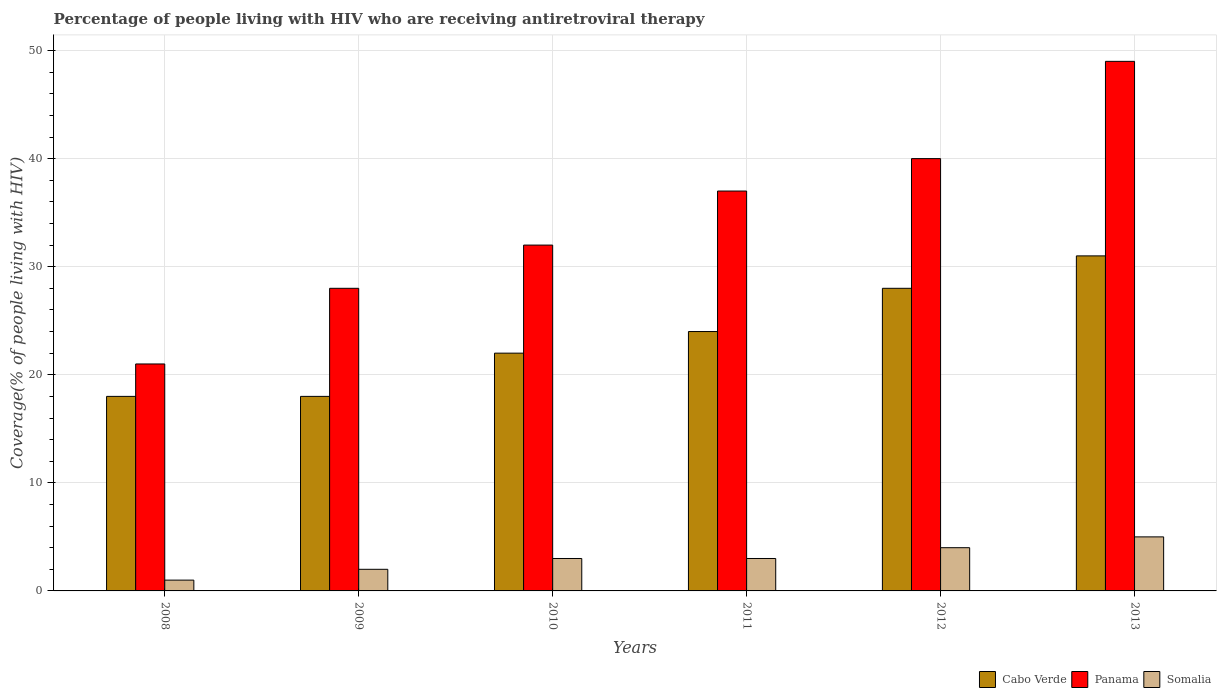Are the number of bars on each tick of the X-axis equal?
Your response must be concise. Yes. How many bars are there on the 1st tick from the left?
Ensure brevity in your answer.  3. What is the label of the 5th group of bars from the left?
Your response must be concise. 2012. What is the percentage of the HIV infected people who are receiving antiretroviral therapy in Cabo Verde in 2013?
Ensure brevity in your answer.  31. Across all years, what is the maximum percentage of the HIV infected people who are receiving antiretroviral therapy in Panama?
Provide a succinct answer. 49. Across all years, what is the minimum percentage of the HIV infected people who are receiving antiretroviral therapy in Cabo Verde?
Your answer should be compact. 18. In which year was the percentage of the HIV infected people who are receiving antiretroviral therapy in Somalia minimum?
Provide a short and direct response. 2008. What is the total percentage of the HIV infected people who are receiving antiretroviral therapy in Panama in the graph?
Provide a short and direct response. 207. What is the difference between the percentage of the HIV infected people who are receiving antiretroviral therapy in Panama in 2008 and that in 2009?
Your response must be concise. -7. What is the difference between the percentage of the HIV infected people who are receiving antiretroviral therapy in Cabo Verde in 2011 and the percentage of the HIV infected people who are receiving antiretroviral therapy in Somalia in 2012?
Provide a succinct answer. 20. In the year 2009, what is the difference between the percentage of the HIV infected people who are receiving antiretroviral therapy in Somalia and percentage of the HIV infected people who are receiving antiretroviral therapy in Panama?
Provide a short and direct response. -26. In how many years, is the percentage of the HIV infected people who are receiving antiretroviral therapy in Cabo Verde greater than 8 %?
Offer a very short reply. 6. What is the ratio of the percentage of the HIV infected people who are receiving antiretroviral therapy in Panama in 2012 to that in 2013?
Your response must be concise. 0.82. Is the difference between the percentage of the HIV infected people who are receiving antiretroviral therapy in Somalia in 2010 and 2013 greater than the difference between the percentage of the HIV infected people who are receiving antiretroviral therapy in Panama in 2010 and 2013?
Give a very brief answer. Yes. What is the difference between the highest and the lowest percentage of the HIV infected people who are receiving antiretroviral therapy in Somalia?
Provide a short and direct response. 4. In how many years, is the percentage of the HIV infected people who are receiving antiretroviral therapy in Somalia greater than the average percentage of the HIV infected people who are receiving antiretroviral therapy in Somalia taken over all years?
Give a very brief answer. 2. Is the sum of the percentage of the HIV infected people who are receiving antiretroviral therapy in Somalia in 2008 and 2012 greater than the maximum percentage of the HIV infected people who are receiving antiretroviral therapy in Panama across all years?
Your answer should be very brief. No. What does the 3rd bar from the left in 2012 represents?
Make the answer very short. Somalia. What does the 3rd bar from the right in 2011 represents?
Provide a succinct answer. Cabo Verde. Is it the case that in every year, the sum of the percentage of the HIV infected people who are receiving antiretroviral therapy in Cabo Verde and percentage of the HIV infected people who are receiving antiretroviral therapy in Panama is greater than the percentage of the HIV infected people who are receiving antiretroviral therapy in Somalia?
Make the answer very short. Yes. How many bars are there?
Make the answer very short. 18. How many years are there in the graph?
Your response must be concise. 6. What is the difference between two consecutive major ticks on the Y-axis?
Provide a short and direct response. 10. Does the graph contain any zero values?
Provide a short and direct response. No. Does the graph contain grids?
Provide a short and direct response. Yes. Where does the legend appear in the graph?
Give a very brief answer. Bottom right. What is the title of the graph?
Offer a very short reply. Percentage of people living with HIV who are receiving antiretroviral therapy. What is the label or title of the Y-axis?
Ensure brevity in your answer.  Coverage(% of people living with HIV). What is the Coverage(% of people living with HIV) of Panama in 2008?
Make the answer very short. 21. What is the Coverage(% of people living with HIV) of Cabo Verde in 2009?
Your response must be concise. 18. What is the Coverage(% of people living with HIV) in Somalia in 2009?
Ensure brevity in your answer.  2. What is the Coverage(% of people living with HIV) in Cabo Verde in 2010?
Ensure brevity in your answer.  22. What is the Coverage(% of people living with HIV) in Somalia in 2010?
Your response must be concise. 3. What is the Coverage(% of people living with HIV) in Cabo Verde in 2011?
Provide a short and direct response. 24. What is the Coverage(% of people living with HIV) in Somalia in 2011?
Make the answer very short. 3. What is the Coverage(% of people living with HIV) of Cabo Verde in 2012?
Offer a terse response. 28. What is the Coverage(% of people living with HIV) of Somalia in 2012?
Your answer should be compact. 4. What is the Coverage(% of people living with HIV) of Somalia in 2013?
Your response must be concise. 5. Across all years, what is the maximum Coverage(% of people living with HIV) of Cabo Verde?
Provide a short and direct response. 31. Across all years, what is the minimum Coverage(% of people living with HIV) in Somalia?
Give a very brief answer. 1. What is the total Coverage(% of people living with HIV) of Cabo Verde in the graph?
Your answer should be very brief. 141. What is the total Coverage(% of people living with HIV) of Panama in the graph?
Make the answer very short. 207. What is the difference between the Coverage(% of people living with HIV) in Panama in 2008 and that in 2009?
Give a very brief answer. -7. What is the difference between the Coverage(% of people living with HIV) of Panama in 2008 and that in 2010?
Offer a terse response. -11. What is the difference between the Coverage(% of people living with HIV) of Somalia in 2008 and that in 2010?
Your answer should be compact. -2. What is the difference between the Coverage(% of people living with HIV) in Cabo Verde in 2008 and that in 2011?
Ensure brevity in your answer.  -6. What is the difference between the Coverage(% of people living with HIV) of Somalia in 2008 and that in 2011?
Provide a succinct answer. -2. What is the difference between the Coverage(% of people living with HIV) of Cabo Verde in 2008 and that in 2012?
Provide a succinct answer. -10. What is the difference between the Coverage(% of people living with HIV) of Somalia in 2008 and that in 2012?
Your answer should be very brief. -3. What is the difference between the Coverage(% of people living with HIV) of Cabo Verde in 2008 and that in 2013?
Provide a succinct answer. -13. What is the difference between the Coverage(% of people living with HIV) in Panama in 2008 and that in 2013?
Ensure brevity in your answer.  -28. What is the difference between the Coverage(% of people living with HIV) of Somalia in 2008 and that in 2013?
Your answer should be compact. -4. What is the difference between the Coverage(% of people living with HIV) of Cabo Verde in 2009 and that in 2010?
Offer a very short reply. -4. What is the difference between the Coverage(% of people living with HIV) of Somalia in 2009 and that in 2010?
Offer a terse response. -1. What is the difference between the Coverage(% of people living with HIV) of Somalia in 2009 and that in 2011?
Your response must be concise. -1. What is the difference between the Coverage(% of people living with HIV) of Panama in 2009 and that in 2012?
Provide a succinct answer. -12. What is the difference between the Coverage(% of people living with HIV) in Somalia in 2009 and that in 2013?
Your answer should be very brief. -3. What is the difference between the Coverage(% of people living with HIV) in Cabo Verde in 2010 and that in 2011?
Provide a succinct answer. -2. What is the difference between the Coverage(% of people living with HIV) of Panama in 2010 and that in 2011?
Provide a short and direct response. -5. What is the difference between the Coverage(% of people living with HIV) in Panama in 2010 and that in 2012?
Provide a succinct answer. -8. What is the difference between the Coverage(% of people living with HIV) in Cabo Verde in 2010 and that in 2013?
Make the answer very short. -9. What is the difference between the Coverage(% of people living with HIV) of Panama in 2010 and that in 2013?
Make the answer very short. -17. What is the difference between the Coverage(% of people living with HIV) of Somalia in 2010 and that in 2013?
Provide a short and direct response. -2. What is the difference between the Coverage(% of people living with HIV) in Cabo Verde in 2011 and that in 2012?
Provide a succinct answer. -4. What is the difference between the Coverage(% of people living with HIV) of Panama in 2011 and that in 2013?
Give a very brief answer. -12. What is the difference between the Coverage(% of people living with HIV) in Somalia in 2011 and that in 2013?
Your answer should be very brief. -2. What is the difference between the Coverage(% of people living with HIV) of Cabo Verde in 2012 and that in 2013?
Provide a succinct answer. -3. What is the difference between the Coverage(% of people living with HIV) in Panama in 2012 and that in 2013?
Offer a terse response. -9. What is the difference between the Coverage(% of people living with HIV) of Somalia in 2012 and that in 2013?
Your answer should be very brief. -1. What is the difference between the Coverage(% of people living with HIV) in Cabo Verde in 2008 and the Coverage(% of people living with HIV) in Panama in 2009?
Make the answer very short. -10. What is the difference between the Coverage(% of people living with HIV) in Cabo Verde in 2008 and the Coverage(% of people living with HIV) in Somalia in 2009?
Your answer should be very brief. 16. What is the difference between the Coverage(% of people living with HIV) of Cabo Verde in 2008 and the Coverage(% of people living with HIV) of Somalia in 2010?
Keep it short and to the point. 15. What is the difference between the Coverage(% of people living with HIV) in Panama in 2008 and the Coverage(% of people living with HIV) in Somalia in 2010?
Offer a very short reply. 18. What is the difference between the Coverage(% of people living with HIV) of Cabo Verde in 2008 and the Coverage(% of people living with HIV) of Panama in 2011?
Make the answer very short. -19. What is the difference between the Coverage(% of people living with HIV) in Panama in 2008 and the Coverage(% of people living with HIV) in Somalia in 2011?
Give a very brief answer. 18. What is the difference between the Coverage(% of people living with HIV) in Cabo Verde in 2008 and the Coverage(% of people living with HIV) in Panama in 2012?
Offer a very short reply. -22. What is the difference between the Coverage(% of people living with HIV) in Cabo Verde in 2008 and the Coverage(% of people living with HIV) in Panama in 2013?
Offer a very short reply. -31. What is the difference between the Coverage(% of people living with HIV) in Panama in 2008 and the Coverage(% of people living with HIV) in Somalia in 2013?
Your answer should be very brief. 16. What is the difference between the Coverage(% of people living with HIV) in Cabo Verde in 2009 and the Coverage(% of people living with HIV) in Somalia in 2010?
Your answer should be compact. 15. What is the difference between the Coverage(% of people living with HIV) in Cabo Verde in 2009 and the Coverage(% of people living with HIV) in Somalia in 2011?
Give a very brief answer. 15. What is the difference between the Coverage(% of people living with HIV) of Panama in 2009 and the Coverage(% of people living with HIV) of Somalia in 2011?
Your response must be concise. 25. What is the difference between the Coverage(% of people living with HIV) in Cabo Verde in 2009 and the Coverage(% of people living with HIV) in Somalia in 2012?
Provide a short and direct response. 14. What is the difference between the Coverage(% of people living with HIV) of Cabo Verde in 2009 and the Coverage(% of people living with HIV) of Panama in 2013?
Make the answer very short. -31. What is the difference between the Coverage(% of people living with HIV) of Cabo Verde in 2009 and the Coverage(% of people living with HIV) of Somalia in 2013?
Your answer should be very brief. 13. What is the difference between the Coverage(% of people living with HIV) of Panama in 2009 and the Coverage(% of people living with HIV) of Somalia in 2013?
Ensure brevity in your answer.  23. What is the difference between the Coverage(% of people living with HIV) in Cabo Verde in 2010 and the Coverage(% of people living with HIV) in Panama in 2011?
Make the answer very short. -15. What is the difference between the Coverage(% of people living with HIV) of Cabo Verde in 2010 and the Coverage(% of people living with HIV) of Somalia in 2011?
Your answer should be compact. 19. What is the difference between the Coverage(% of people living with HIV) in Cabo Verde in 2010 and the Coverage(% of people living with HIV) in Panama in 2012?
Your answer should be compact. -18. What is the difference between the Coverage(% of people living with HIV) in Cabo Verde in 2010 and the Coverage(% of people living with HIV) in Somalia in 2012?
Give a very brief answer. 18. What is the difference between the Coverage(% of people living with HIV) of Cabo Verde in 2010 and the Coverage(% of people living with HIV) of Panama in 2013?
Ensure brevity in your answer.  -27. What is the difference between the Coverage(% of people living with HIV) in Cabo Verde in 2010 and the Coverage(% of people living with HIV) in Somalia in 2013?
Your answer should be very brief. 17. What is the difference between the Coverage(% of people living with HIV) in Panama in 2010 and the Coverage(% of people living with HIV) in Somalia in 2013?
Your answer should be very brief. 27. What is the difference between the Coverage(% of people living with HIV) in Panama in 2011 and the Coverage(% of people living with HIV) in Somalia in 2012?
Give a very brief answer. 33. What is the difference between the Coverage(% of people living with HIV) in Cabo Verde in 2011 and the Coverage(% of people living with HIV) in Panama in 2013?
Offer a terse response. -25. What is the difference between the Coverage(% of people living with HIV) in Panama in 2011 and the Coverage(% of people living with HIV) in Somalia in 2013?
Make the answer very short. 32. What is the average Coverage(% of people living with HIV) in Cabo Verde per year?
Your answer should be compact. 23.5. What is the average Coverage(% of people living with HIV) of Panama per year?
Keep it short and to the point. 34.5. What is the average Coverage(% of people living with HIV) in Somalia per year?
Your answer should be compact. 3. In the year 2008, what is the difference between the Coverage(% of people living with HIV) in Cabo Verde and Coverage(% of people living with HIV) in Panama?
Make the answer very short. -3. In the year 2008, what is the difference between the Coverage(% of people living with HIV) in Cabo Verde and Coverage(% of people living with HIV) in Somalia?
Your answer should be very brief. 17. In the year 2009, what is the difference between the Coverage(% of people living with HIV) in Cabo Verde and Coverage(% of people living with HIV) in Panama?
Make the answer very short. -10. In the year 2010, what is the difference between the Coverage(% of people living with HIV) of Cabo Verde and Coverage(% of people living with HIV) of Panama?
Provide a short and direct response. -10. In the year 2010, what is the difference between the Coverage(% of people living with HIV) of Cabo Verde and Coverage(% of people living with HIV) of Somalia?
Make the answer very short. 19. In the year 2010, what is the difference between the Coverage(% of people living with HIV) of Panama and Coverage(% of people living with HIV) of Somalia?
Your answer should be very brief. 29. In the year 2011, what is the difference between the Coverage(% of people living with HIV) in Cabo Verde and Coverage(% of people living with HIV) in Panama?
Your response must be concise. -13. In the year 2011, what is the difference between the Coverage(% of people living with HIV) of Cabo Verde and Coverage(% of people living with HIV) of Somalia?
Your response must be concise. 21. In the year 2011, what is the difference between the Coverage(% of people living with HIV) in Panama and Coverage(% of people living with HIV) in Somalia?
Your answer should be very brief. 34. In the year 2012, what is the difference between the Coverage(% of people living with HIV) in Cabo Verde and Coverage(% of people living with HIV) in Panama?
Provide a succinct answer. -12. In the year 2012, what is the difference between the Coverage(% of people living with HIV) in Panama and Coverage(% of people living with HIV) in Somalia?
Your answer should be compact. 36. In the year 2013, what is the difference between the Coverage(% of people living with HIV) of Cabo Verde and Coverage(% of people living with HIV) of Somalia?
Ensure brevity in your answer.  26. What is the ratio of the Coverage(% of people living with HIV) in Panama in 2008 to that in 2009?
Provide a short and direct response. 0.75. What is the ratio of the Coverage(% of people living with HIV) of Cabo Verde in 2008 to that in 2010?
Give a very brief answer. 0.82. What is the ratio of the Coverage(% of people living with HIV) of Panama in 2008 to that in 2010?
Offer a very short reply. 0.66. What is the ratio of the Coverage(% of people living with HIV) in Panama in 2008 to that in 2011?
Make the answer very short. 0.57. What is the ratio of the Coverage(% of people living with HIV) of Somalia in 2008 to that in 2011?
Offer a very short reply. 0.33. What is the ratio of the Coverage(% of people living with HIV) in Cabo Verde in 2008 to that in 2012?
Provide a succinct answer. 0.64. What is the ratio of the Coverage(% of people living with HIV) in Panama in 2008 to that in 2012?
Your response must be concise. 0.53. What is the ratio of the Coverage(% of people living with HIV) in Somalia in 2008 to that in 2012?
Your answer should be compact. 0.25. What is the ratio of the Coverage(% of people living with HIV) of Cabo Verde in 2008 to that in 2013?
Make the answer very short. 0.58. What is the ratio of the Coverage(% of people living with HIV) of Panama in 2008 to that in 2013?
Give a very brief answer. 0.43. What is the ratio of the Coverage(% of people living with HIV) of Somalia in 2008 to that in 2013?
Your answer should be compact. 0.2. What is the ratio of the Coverage(% of people living with HIV) of Cabo Verde in 2009 to that in 2010?
Make the answer very short. 0.82. What is the ratio of the Coverage(% of people living with HIV) of Somalia in 2009 to that in 2010?
Make the answer very short. 0.67. What is the ratio of the Coverage(% of people living with HIV) in Panama in 2009 to that in 2011?
Offer a very short reply. 0.76. What is the ratio of the Coverage(% of people living with HIV) of Cabo Verde in 2009 to that in 2012?
Keep it short and to the point. 0.64. What is the ratio of the Coverage(% of people living with HIV) of Cabo Verde in 2009 to that in 2013?
Keep it short and to the point. 0.58. What is the ratio of the Coverage(% of people living with HIV) in Panama in 2009 to that in 2013?
Your answer should be very brief. 0.57. What is the ratio of the Coverage(% of people living with HIV) in Somalia in 2009 to that in 2013?
Make the answer very short. 0.4. What is the ratio of the Coverage(% of people living with HIV) in Panama in 2010 to that in 2011?
Keep it short and to the point. 0.86. What is the ratio of the Coverage(% of people living with HIV) of Somalia in 2010 to that in 2011?
Provide a succinct answer. 1. What is the ratio of the Coverage(% of people living with HIV) of Cabo Verde in 2010 to that in 2012?
Offer a terse response. 0.79. What is the ratio of the Coverage(% of people living with HIV) of Panama in 2010 to that in 2012?
Your answer should be very brief. 0.8. What is the ratio of the Coverage(% of people living with HIV) of Somalia in 2010 to that in 2012?
Your answer should be compact. 0.75. What is the ratio of the Coverage(% of people living with HIV) of Cabo Verde in 2010 to that in 2013?
Your answer should be compact. 0.71. What is the ratio of the Coverage(% of people living with HIV) in Panama in 2010 to that in 2013?
Your answer should be compact. 0.65. What is the ratio of the Coverage(% of people living with HIV) of Cabo Verde in 2011 to that in 2012?
Your answer should be compact. 0.86. What is the ratio of the Coverage(% of people living with HIV) of Panama in 2011 to that in 2012?
Your response must be concise. 0.93. What is the ratio of the Coverage(% of people living with HIV) in Cabo Verde in 2011 to that in 2013?
Your answer should be very brief. 0.77. What is the ratio of the Coverage(% of people living with HIV) of Panama in 2011 to that in 2013?
Give a very brief answer. 0.76. What is the ratio of the Coverage(% of people living with HIV) of Somalia in 2011 to that in 2013?
Your answer should be compact. 0.6. What is the ratio of the Coverage(% of people living with HIV) in Cabo Verde in 2012 to that in 2013?
Give a very brief answer. 0.9. What is the ratio of the Coverage(% of people living with HIV) in Panama in 2012 to that in 2013?
Provide a short and direct response. 0.82. What is the difference between the highest and the second highest Coverage(% of people living with HIV) of Cabo Verde?
Your answer should be compact. 3. What is the difference between the highest and the lowest Coverage(% of people living with HIV) of Panama?
Offer a terse response. 28. What is the difference between the highest and the lowest Coverage(% of people living with HIV) of Somalia?
Give a very brief answer. 4. 